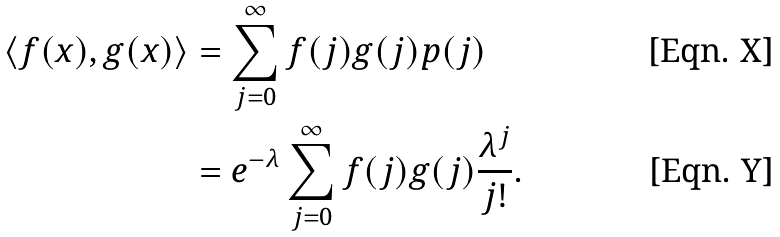<formula> <loc_0><loc_0><loc_500><loc_500>\langle f ( x ) , g ( x ) \rangle & = \sum _ { j = 0 } ^ { \infty } f ( j ) g ( j ) p ( j ) \\ & = e ^ { - \lambda } \sum _ { j = 0 } ^ { \infty } f ( j ) g ( j ) \frac { \lambda ^ { j } } { j ! } .</formula> 